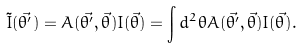Convert formula to latex. <formula><loc_0><loc_0><loc_500><loc_500>\tilde { I } ( \vec { \theta ^ { \prime } } ) = { A } ( \vec { \theta ^ { \prime } } , \vec { \theta } ) I ( \vec { \theta } ) = \int { d ^ { 2 } \theta A ( \vec { \theta ^ { \prime } } , \vec { \theta } ) I ( \vec { \theta } ) } .</formula> 